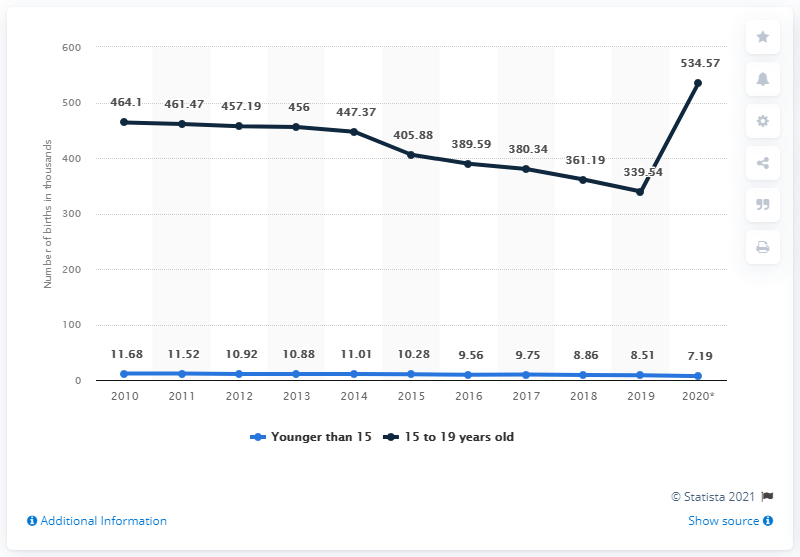Point out several critical features in this image. Since 2010, the number of births registered among women and girls younger than 20 in Mexico has been decreasing. 